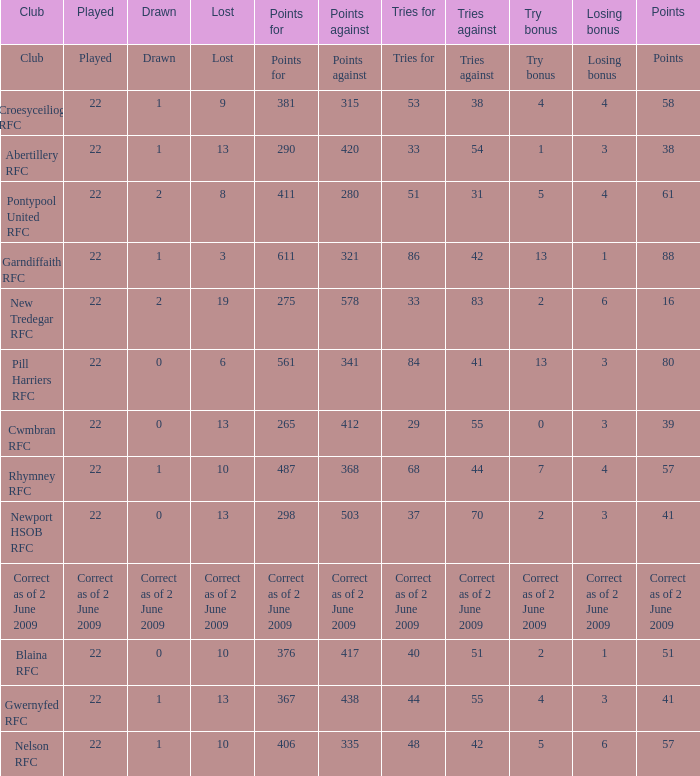Which club has 275 points? New Tredegar RFC. 